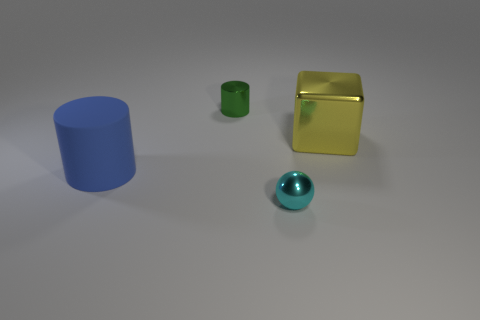There is a small thing that is in front of the small green metal cylinder; what material is it?
Give a very brief answer. Metal. The green metal thing that is the same shape as the matte object is what size?
Give a very brief answer. Small. Are there fewer yellow objects in front of the tiny cyan ball than tiny yellow shiny objects?
Offer a very short reply. No. Are there any red metal balls?
Offer a terse response. No. The large thing that is the same shape as the tiny green shiny thing is what color?
Your answer should be compact. Blue. There is a tiny metal object that is on the left side of the small cyan metal ball; is it the same color as the large matte object?
Provide a succinct answer. No. Do the cyan ball and the green metallic object have the same size?
Provide a succinct answer. Yes. There is a tiny green thing that is made of the same material as the big block; what shape is it?
Your response must be concise. Cylinder. How many other things are there of the same shape as the yellow object?
Offer a very short reply. 0. What is the shape of the large object to the left of the tiny object to the left of the small metallic thing to the right of the green cylinder?
Your answer should be very brief. Cylinder. 